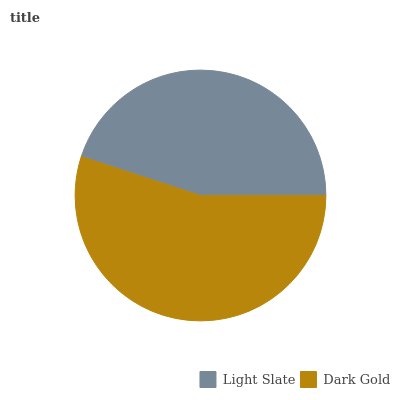Is Light Slate the minimum?
Answer yes or no. Yes. Is Dark Gold the maximum?
Answer yes or no. Yes. Is Dark Gold the minimum?
Answer yes or no. No. Is Dark Gold greater than Light Slate?
Answer yes or no. Yes. Is Light Slate less than Dark Gold?
Answer yes or no. Yes. Is Light Slate greater than Dark Gold?
Answer yes or no. No. Is Dark Gold less than Light Slate?
Answer yes or no. No. Is Dark Gold the high median?
Answer yes or no. Yes. Is Light Slate the low median?
Answer yes or no. Yes. Is Light Slate the high median?
Answer yes or no. No. Is Dark Gold the low median?
Answer yes or no. No. 